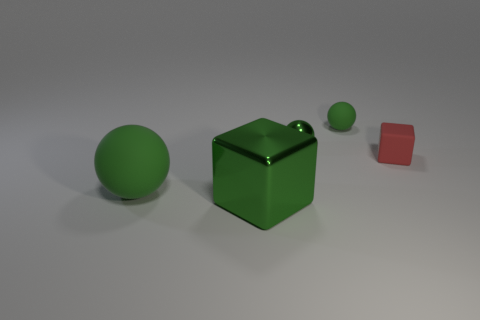Add 1 gray metal spheres. How many objects exist? 6 Subtract all blocks. How many objects are left? 3 Add 5 tiny metal objects. How many tiny metal objects are left? 6 Add 4 big green cylinders. How many big green cylinders exist? 4 Subtract 0 red spheres. How many objects are left? 5 Subtract all large red rubber spheres. Subtract all tiny green shiny objects. How many objects are left? 4 